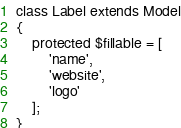<code> <loc_0><loc_0><loc_500><loc_500><_PHP_>class Label extends Model
{
    protected $fillable = [
        'name',
        'website', 
        'logo'
    ];
}
</code> 